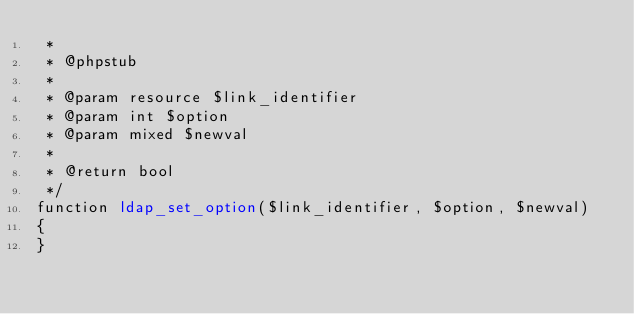<code> <loc_0><loc_0><loc_500><loc_500><_PHP_> *
 * @phpstub
 *
 * @param resource $link_identifier
 * @param int $option
 * @param mixed $newval
 *
 * @return bool 
 */
function ldap_set_option($link_identifier, $option, $newval)
{
}</code> 